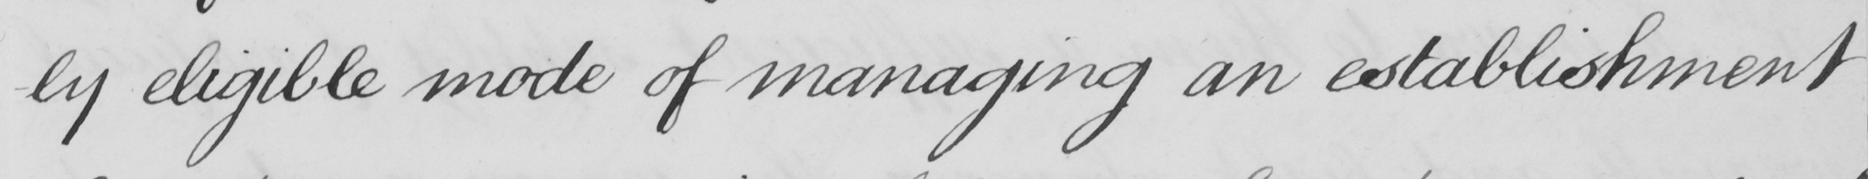What is written in this line of handwriting? -ly eligible mode of managing an establishment 